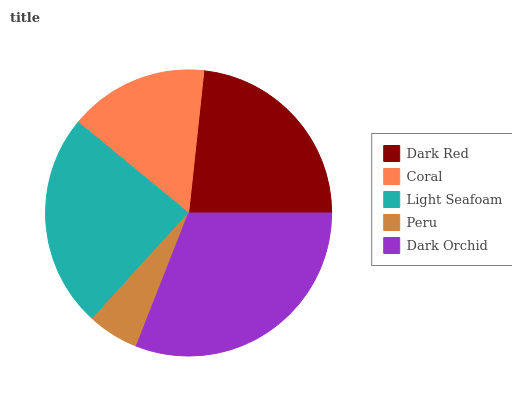Is Peru the minimum?
Answer yes or no. Yes. Is Dark Orchid the maximum?
Answer yes or no. Yes. Is Coral the minimum?
Answer yes or no. No. Is Coral the maximum?
Answer yes or no. No. Is Dark Red greater than Coral?
Answer yes or no. Yes. Is Coral less than Dark Red?
Answer yes or no. Yes. Is Coral greater than Dark Red?
Answer yes or no. No. Is Dark Red less than Coral?
Answer yes or no. No. Is Dark Red the high median?
Answer yes or no. Yes. Is Dark Red the low median?
Answer yes or no. Yes. Is Peru the high median?
Answer yes or no. No. Is Coral the low median?
Answer yes or no. No. 